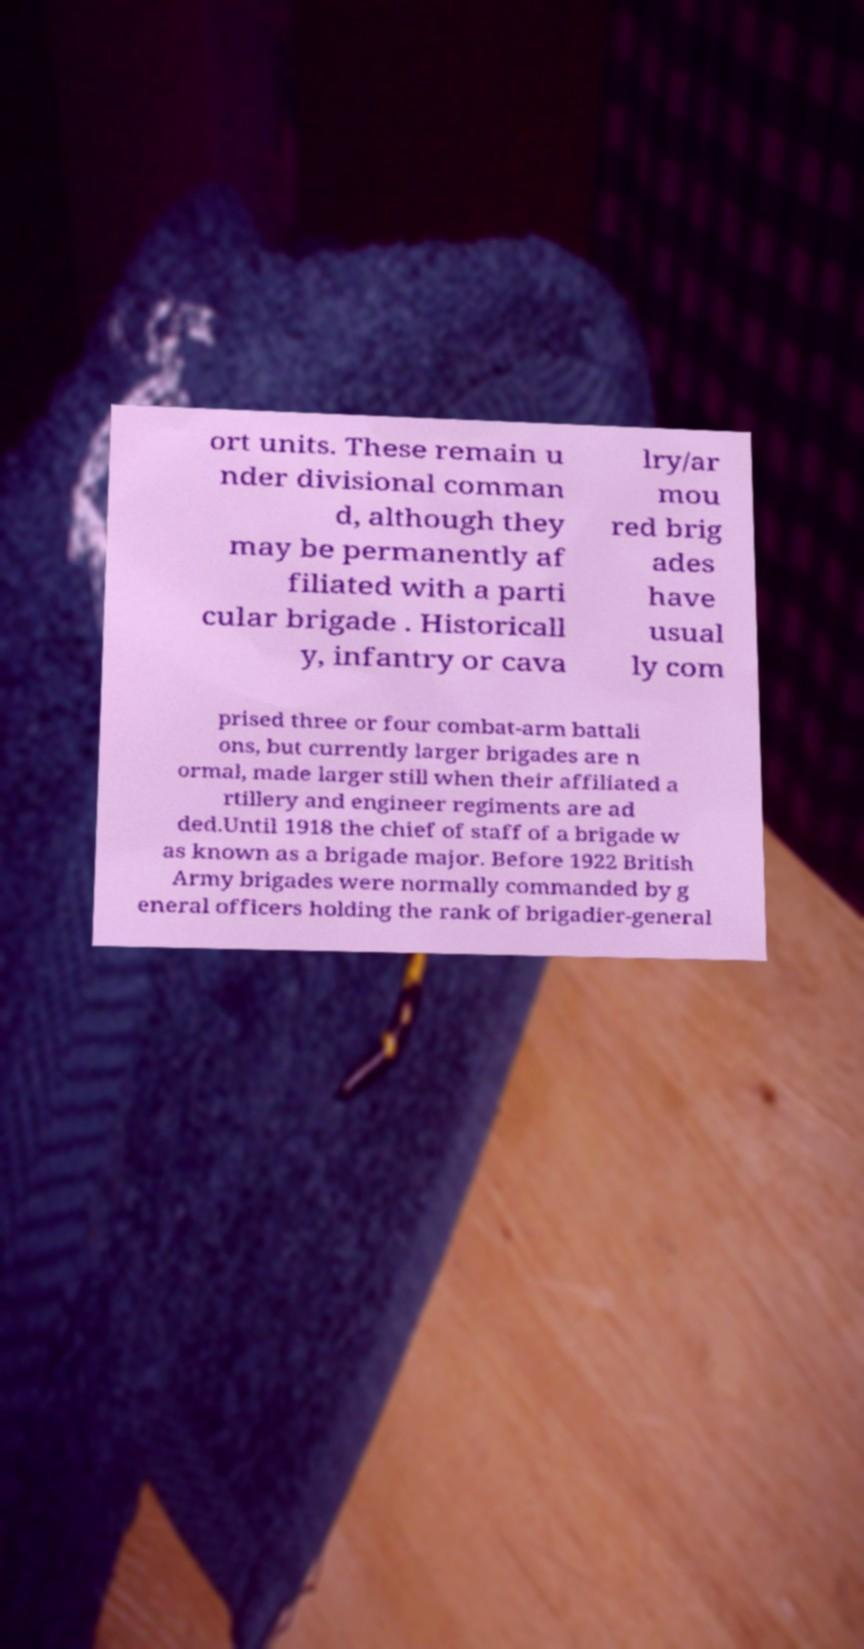Please identify and transcribe the text found in this image. ort units. These remain u nder divisional comman d, although they may be permanently af filiated with a parti cular brigade . Historicall y, infantry or cava lry/ar mou red brig ades have usual ly com prised three or four combat-arm battali ons, but currently larger brigades are n ormal, made larger still when their affiliated a rtillery and engineer regiments are ad ded.Until 1918 the chief of staff of a brigade w as known as a brigade major. Before 1922 British Army brigades were normally commanded by g eneral officers holding the rank of brigadier-general 